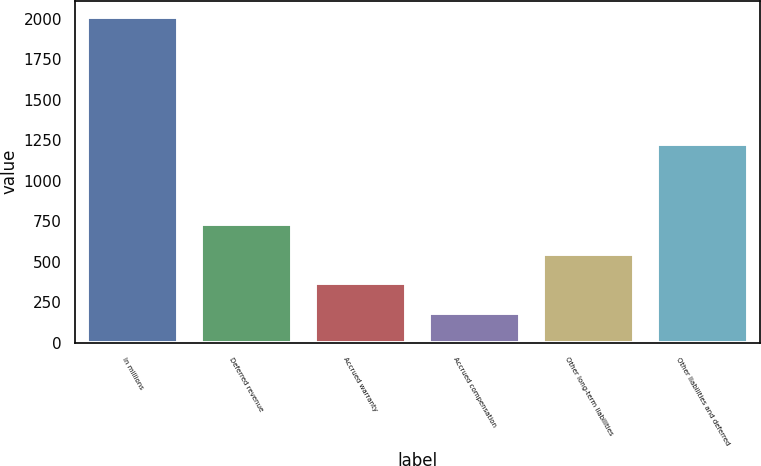Convert chart. <chart><loc_0><loc_0><loc_500><loc_500><bar_chart><fcel>In millions<fcel>Deferred revenue<fcel>Accrued warranty<fcel>Accrued compensation<fcel>Other long-term liabilities<fcel>Other liabilities and deferred<nl><fcel>2013<fcel>732.7<fcel>366.9<fcel>184<fcel>549.8<fcel>1230<nl></chart> 